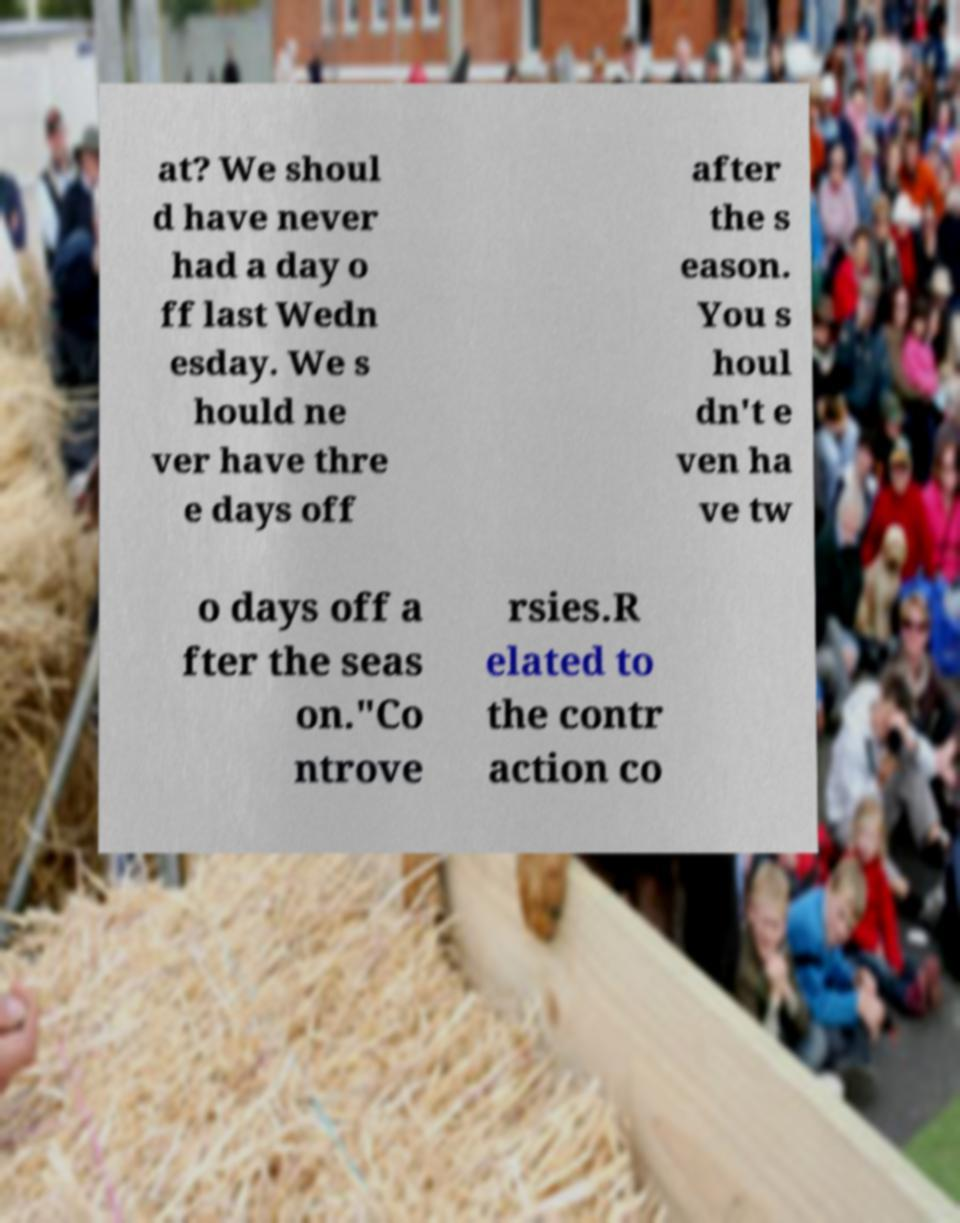Could you extract and type out the text from this image? at? We shoul d have never had a day o ff last Wedn esday. We s hould ne ver have thre e days off after the s eason. You s houl dn't e ven ha ve tw o days off a fter the seas on."Co ntrove rsies.R elated to the contr action co 